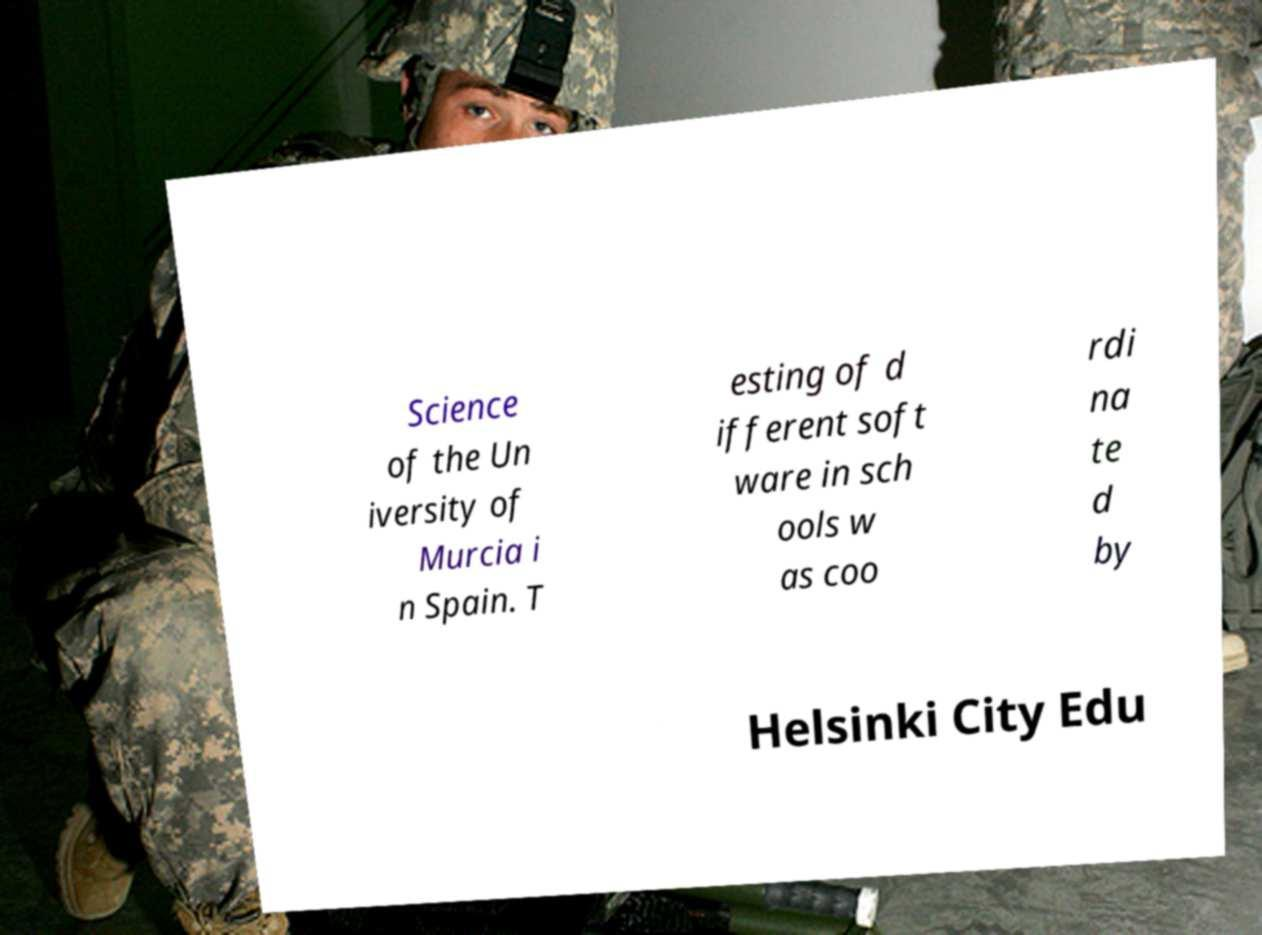For documentation purposes, I need the text within this image transcribed. Could you provide that? Science of the Un iversity of Murcia i n Spain. T esting of d ifferent soft ware in sch ools w as coo rdi na te d by Helsinki City Edu 